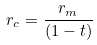Convert formula to latex. <formula><loc_0><loc_0><loc_500><loc_500>r _ { c } = \frac { r _ { m } } { ( 1 - t ) }</formula> 